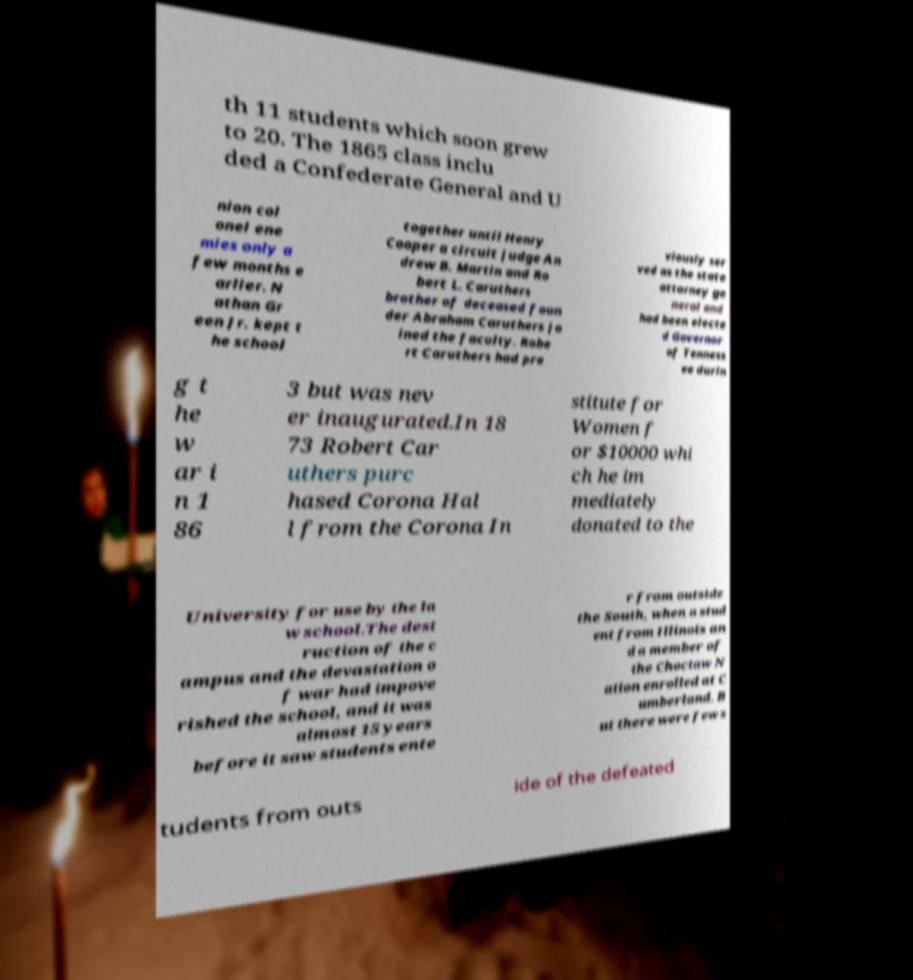Can you read and provide the text displayed in the image?This photo seems to have some interesting text. Can you extract and type it out for me? th 11 students which soon grew to 20. The 1865 class inclu ded a Confederate General and U nion col onel ene mies only a few months e arlier. N athan Gr een Jr. kept t he school together until Henry Cooper a circuit judge An drew B. Martin and Ro bert L. Caruthers brother of deceased foun der Abraham Caruthers jo ined the faculty. Robe rt Caruthers had pre viously ser ved as the state attorney ge neral and had been electe d Governor of Tenness ee durin g t he w ar i n 1 86 3 but was nev er inaugurated.In 18 73 Robert Car uthers purc hased Corona Hal l from the Corona In stitute for Women f or $10000 whi ch he im mediately donated to the University for use by the la w school.The dest ruction of the c ampus and the devastation o f war had impove rished the school, and it was almost 15 years before it saw students ente r from outside the South, when a stud ent from Illinois an d a member of the Choctaw N ation enrolled at C umberland. B ut there were few s tudents from outs ide of the defeated 